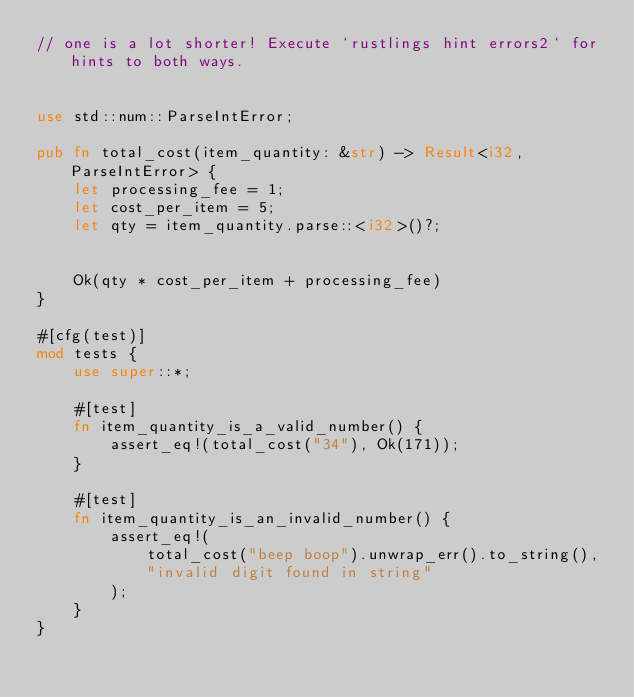<code> <loc_0><loc_0><loc_500><loc_500><_Rust_>// one is a lot shorter! Execute `rustlings hint errors2` for hints to both ways.


use std::num::ParseIntError;

pub fn total_cost(item_quantity: &str) -> Result<i32, ParseIntError> {
    let processing_fee = 1;
    let cost_per_item = 5;
    let qty = item_quantity.parse::<i32>()?;
    

    Ok(qty * cost_per_item + processing_fee)
}

#[cfg(test)]
mod tests {
    use super::*;

    #[test]
    fn item_quantity_is_a_valid_number() {
        assert_eq!(total_cost("34"), Ok(171));
    }

    #[test]
    fn item_quantity_is_an_invalid_number() {
        assert_eq!(
            total_cost("beep boop").unwrap_err().to_string(),
            "invalid digit found in string"
        );
    }
}
</code> 